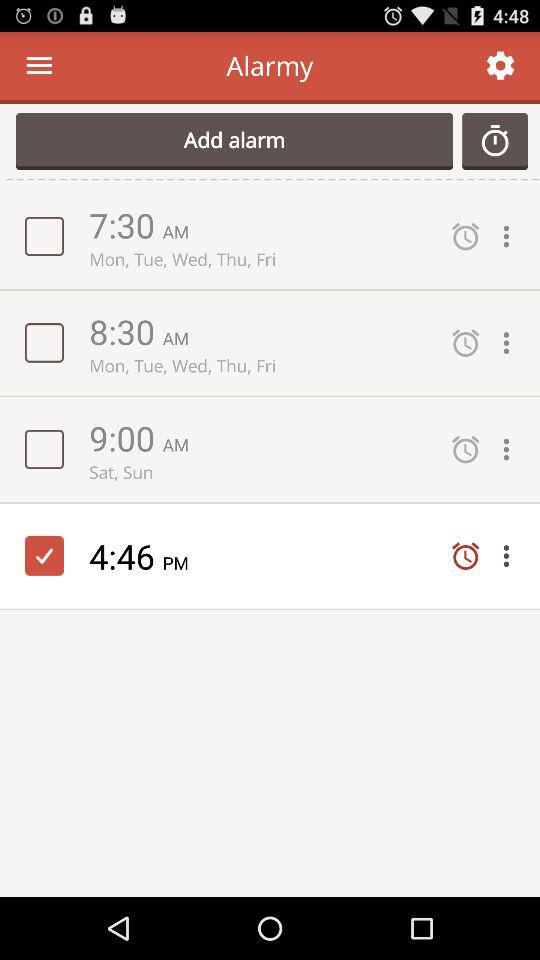Which alarm is set for the latest time?
Answer the question using a single word or phrase. 4:46 PM 